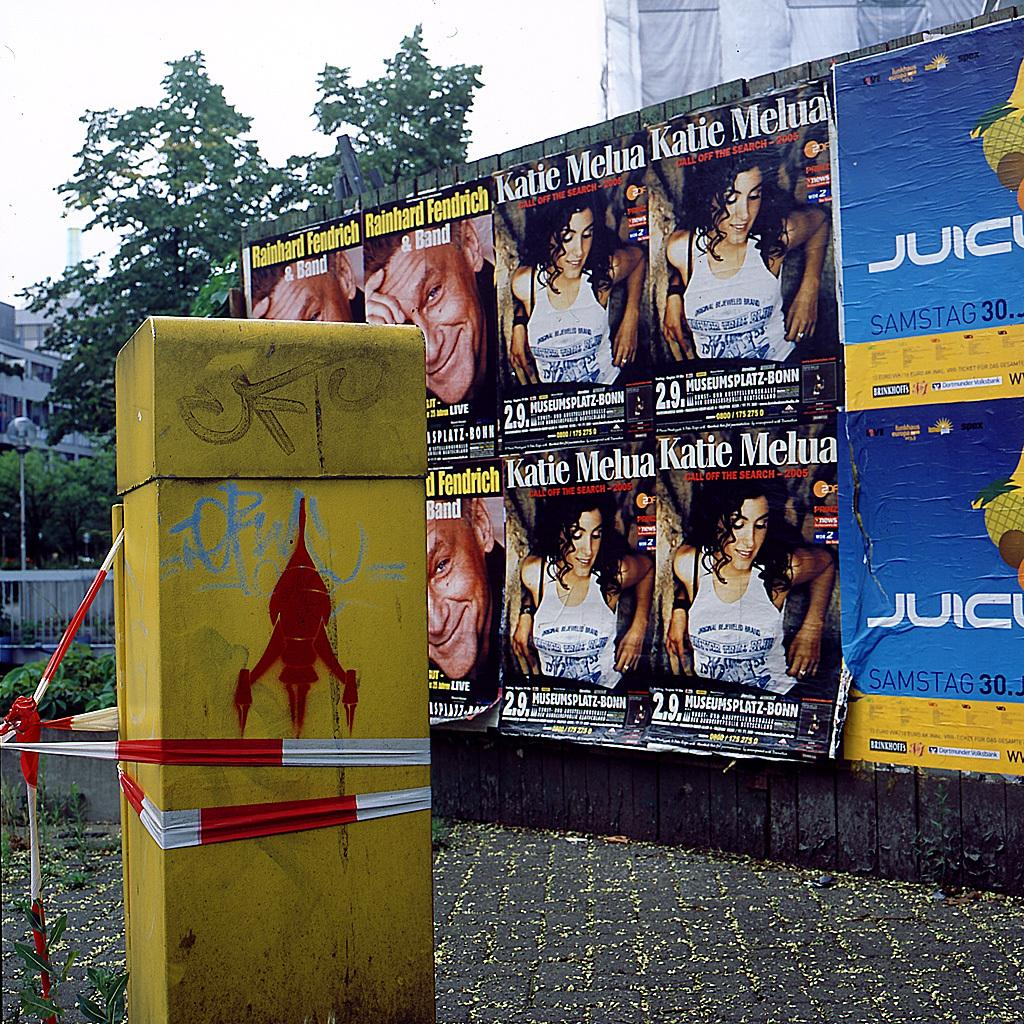Provide a one-sentence caption for the provided image. A gratified pillar that has been wrapped with police tap and a wall in the background that has some posters on it, some of which are for Katie Melua. 